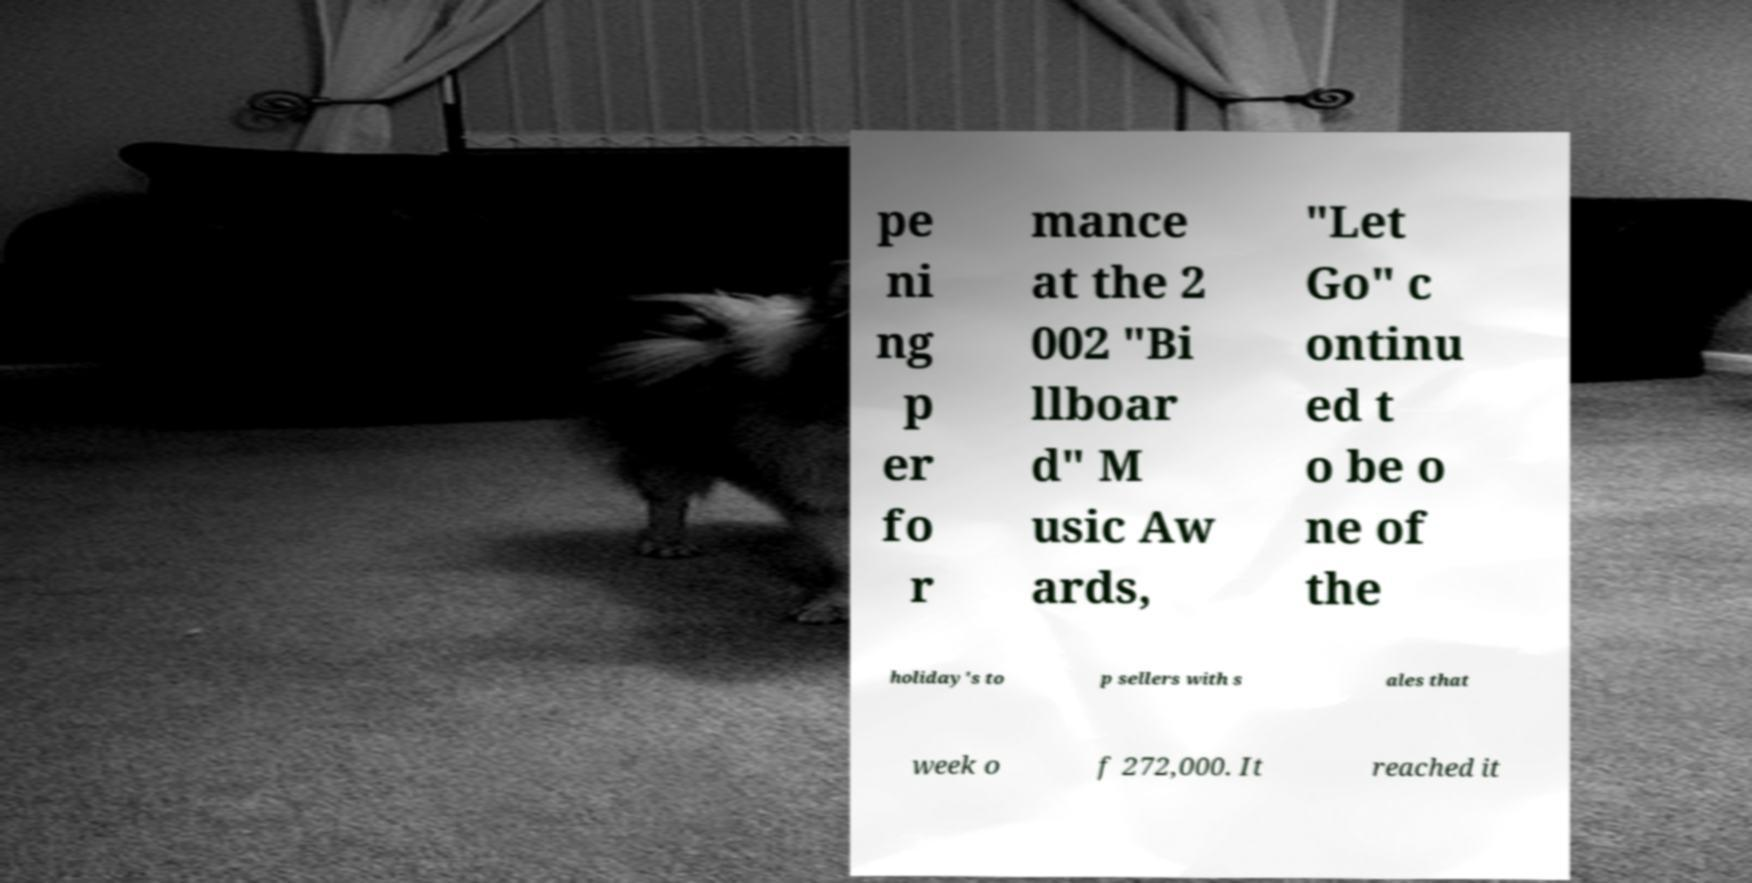What messages or text are displayed in this image? I need them in a readable, typed format. pe ni ng p er fo r mance at the 2 002 "Bi llboar d" M usic Aw ards, "Let Go" c ontinu ed t o be o ne of the holiday's to p sellers with s ales that week o f 272,000. It reached it 